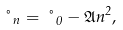Convert formula to latex. <formula><loc_0><loc_0><loc_500><loc_500>\nu _ { n } = \nu _ { 0 } - \mathfrak { A } n ^ { 2 } ,</formula> 